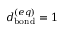Convert formula to latex. <formula><loc_0><loc_0><loc_500><loc_500>d _ { b o n d } ^ { ( e q ) } = 1 \, \AA</formula> 